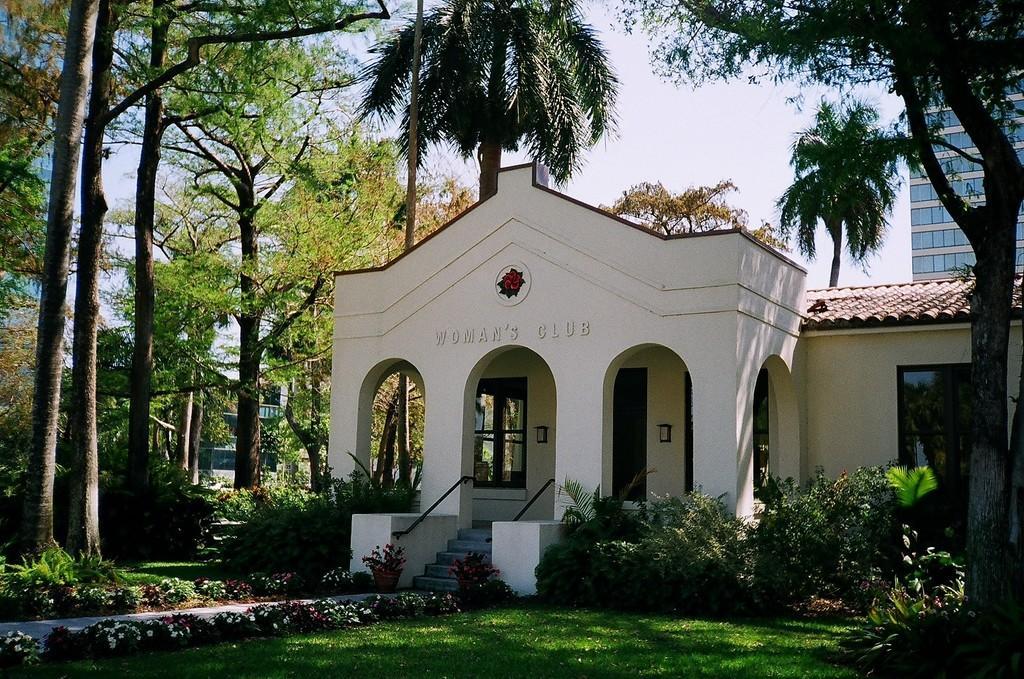How would you summarize this image in a sentence or two? In this image I can able to see buildings, stairs, door,windows,plants,trees, flowers, grass and in the background there is sky. 